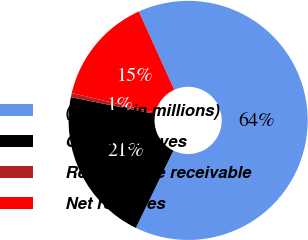<chart> <loc_0><loc_0><loc_500><loc_500><pie_chart><fcel>(Dollars in millions)<fcel>Gross reserves<fcel>Reinsurance receivable<fcel>Net reserves<nl><fcel>63.98%<fcel>20.9%<fcel>0.57%<fcel>14.56%<nl></chart> 